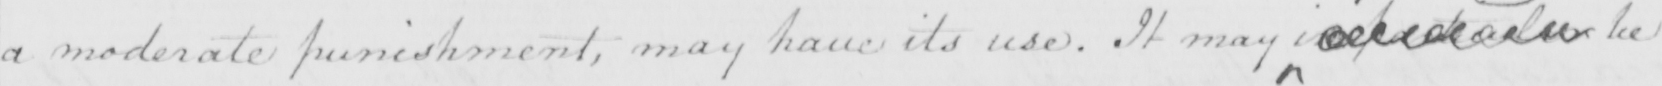What does this handwritten line say? a moderate punishment , may have its use . It may  <gap/>   <gap/>  be 